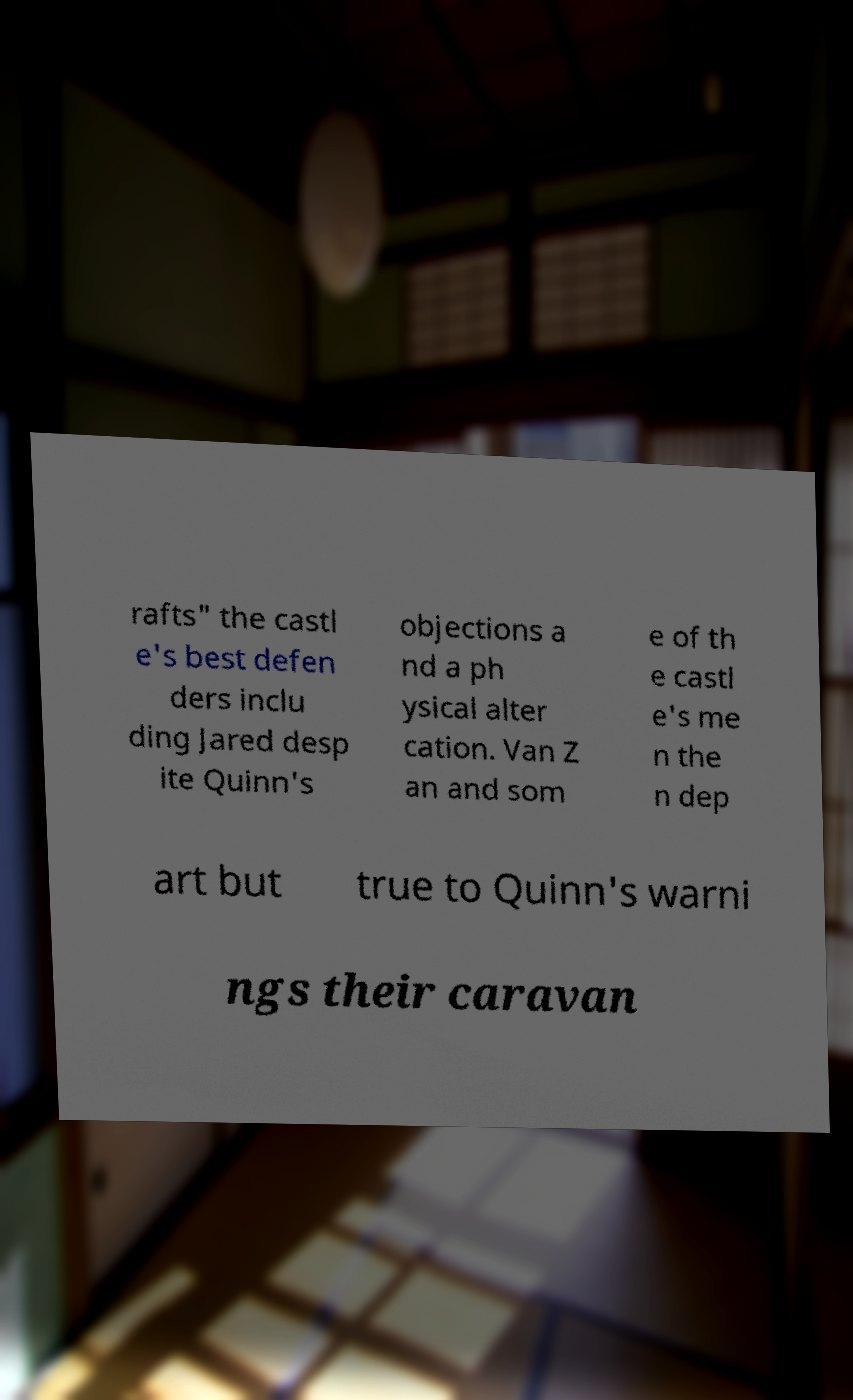There's text embedded in this image that I need extracted. Can you transcribe it verbatim? rafts" the castl e's best defen ders inclu ding Jared desp ite Quinn's objections a nd a ph ysical alter cation. Van Z an and som e of th e castl e's me n the n dep art but true to Quinn's warni ngs their caravan 